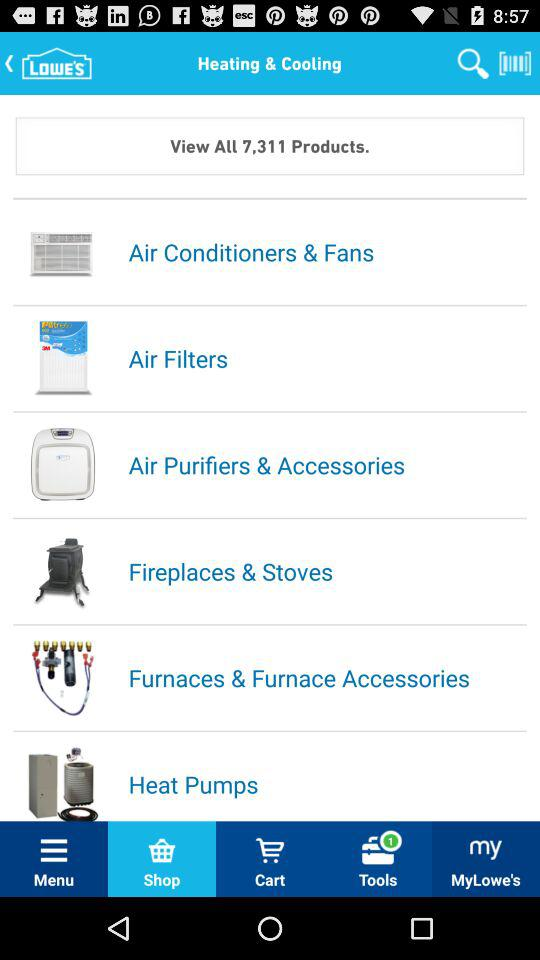Which tab is selected? The selected tab is "Shop". 